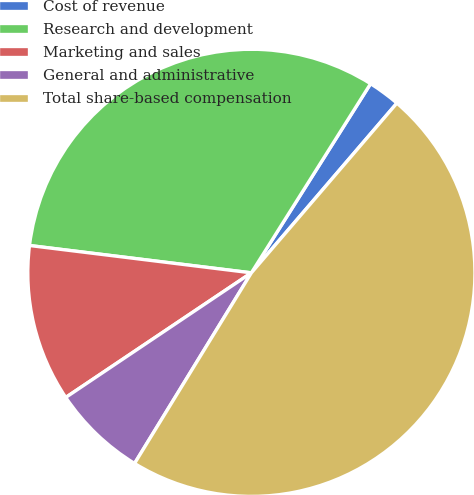Convert chart. <chart><loc_0><loc_0><loc_500><loc_500><pie_chart><fcel>Cost of revenue<fcel>Research and development<fcel>Marketing and sales<fcel>General and administrative<fcel>Total share-based compensation<nl><fcel>2.33%<fcel>32.0%<fcel>11.36%<fcel>6.84%<fcel>47.47%<nl></chart> 